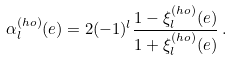Convert formula to latex. <formula><loc_0><loc_0><loc_500><loc_500>\alpha ^ { ( h o ) } _ { l } ( e ) = 2 ( - 1 ) ^ { l } \frac { 1 - \xi ^ { ( h o ) } _ { l } ( e ) } { 1 + \xi ^ { ( h o ) } _ { l } ( e ) } \, .</formula> 